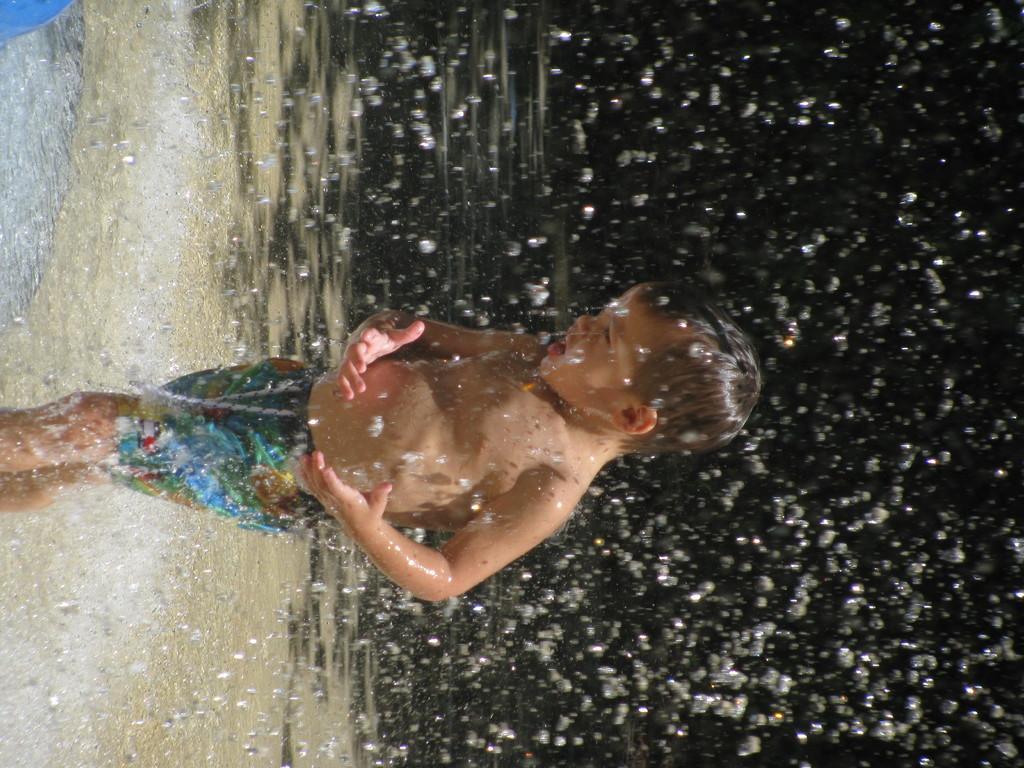Could you give a brief overview of what you see in this image? In this picture, we see a boy is standing. On the left side, we see water. In the left top, we see a blue color object. It might be raining. On the right side, it is black in color. 